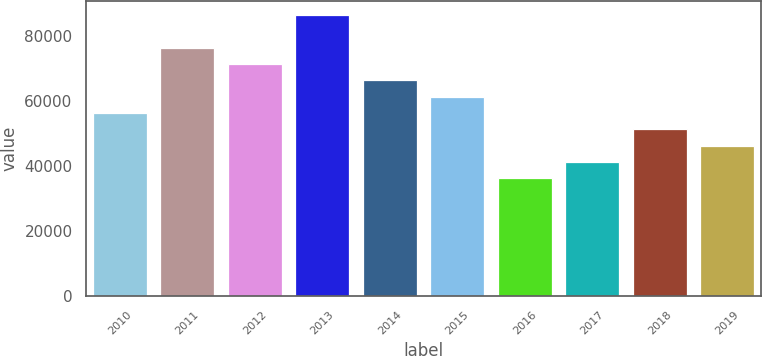Convert chart. <chart><loc_0><loc_0><loc_500><loc_500><bar_chart><fcel>2010<fcel>2011<fcel>2012<fcel>2013<fcel>2014<fcel>2015<fcel>2016<fcel>2017<fcel>2018<fcel>2019<nl><fcel>56210<fcel>76214<fcel>71213<fcel>86216<fcel>66212<fcel>61211<fcel>36206<fcel>41207<fcel>51209<fcel>46208<nl></chart> 